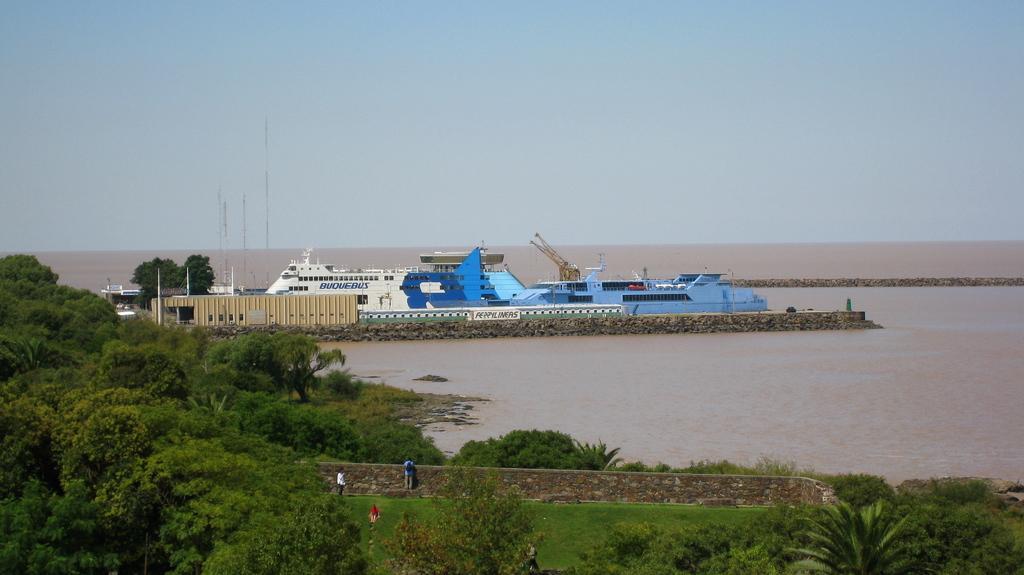Describe this image in one or two sentences. This image is taken outdoors. At the top of the image there is a sky. At the bottom of the image there is a ground with grass on it and there are many trees and plants on the ground. In the middle of the image there is a pond with water and there are two ships and a house and there are a few poles and iron bars. A man is standing on the ground and there is a wall. 